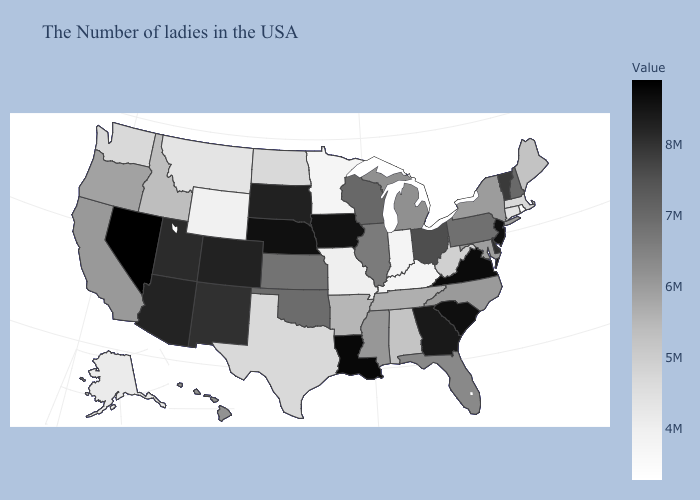Does Arizona have the highest value in the USA?
Concise answer only. No. Among the states that border Michigan , does Wisconsin have the highest value?
Concise answer only. No. Does New Hampshire have the lowest value in the Northeast?
Give a very brief answer. No. Among the states that border New Mexico , which have the lowest value?
Short answer required. Texas. Does Nevada have the highest value in the West?
Be succinct. Yes. 